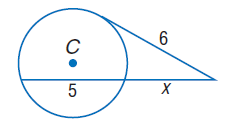Answer the mathemtical geometry problem and directly provide the correct option letter.
Question: Find x. Assume that segments that appear to be tangent are tangent.
Choices: A: 4 B: 6 C: 8 D: 10 A 